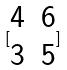<formula> <loc_0><loc_0><loc_500><loc_500>[ \begin{matrix} 4 & 6 \\ 3 & 5 \end{matrix} ]</formula> 